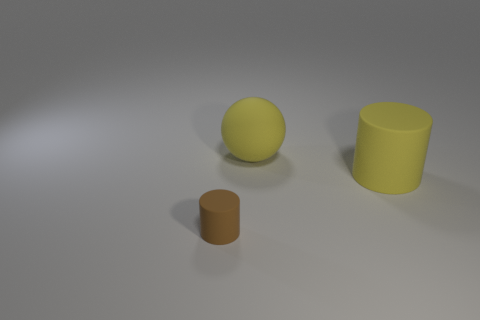Add 1 brown things. How many objects exist? 4 Subtract all spheres. How many objects are left? 2 Subtract 0 blue blocks. How many objects are left? 3 Subtract all brown rubber objects. Subtract all large yellow balls. How many objects are left? 1 Add 2 big matte cylinders. How many big matte cylinders are left? 3 Add 3 small cylinders. How many small cylinders exist? 4 